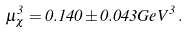<formula> <loc_0><loc_0><loc_500><loc_500>\mu _ { \chi } ^ { 3 } = 0 . 1 4 0 \pm 0 . 0 4 3 G e V ^ { 3 } \, .</formula> 